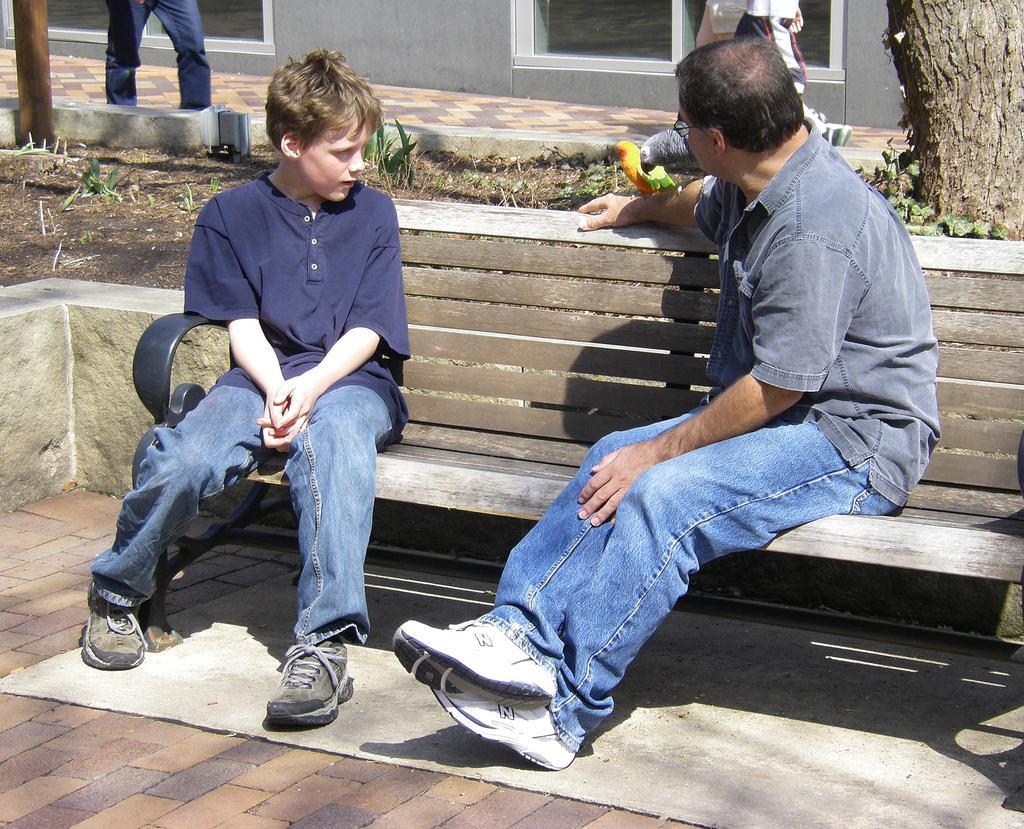Could you give a brief overview of what you see in this image? There is a man and a boy sitting on the bench. The man wore a grey color shirt and a blue jeans with white shoes. The boy wore a navy blue color t-shirt and blue jeans with green color shoes. There is a person standing in the background. There is also a wall and glass. There is tree trunk and also leaves just beside the trunk. There is grass on the land. 